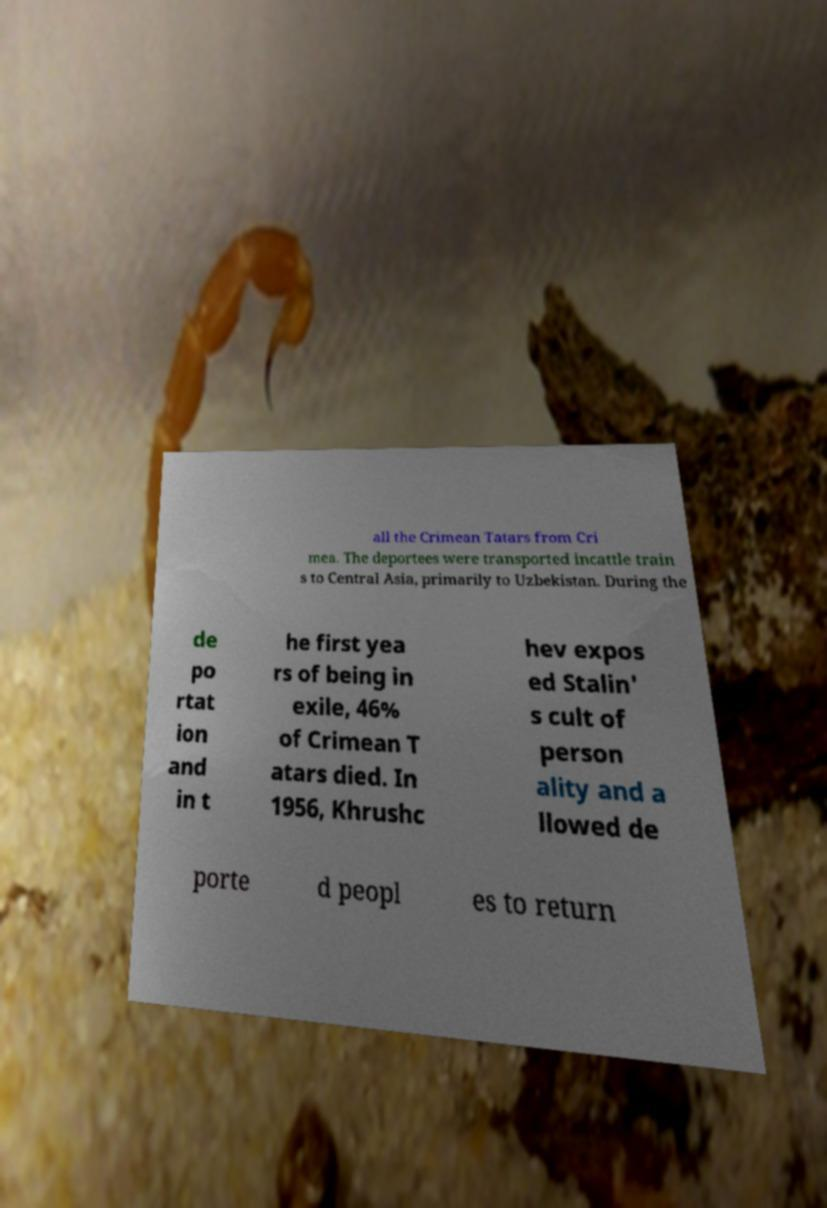I need the written content from this picture converted into text. Can you do that? all the Crimean Tatars from Cri mea. The deportees were transported incattle train s to Central Asia, primarily to Uzbekistan. During the de po rtat ion and in t he first yea rs of being in exile, 46% of Crimean T atars died. In 1956, Khrushc hev expos ed Stalin' s cult of person ality and a llowed de porte d peopl es to return 